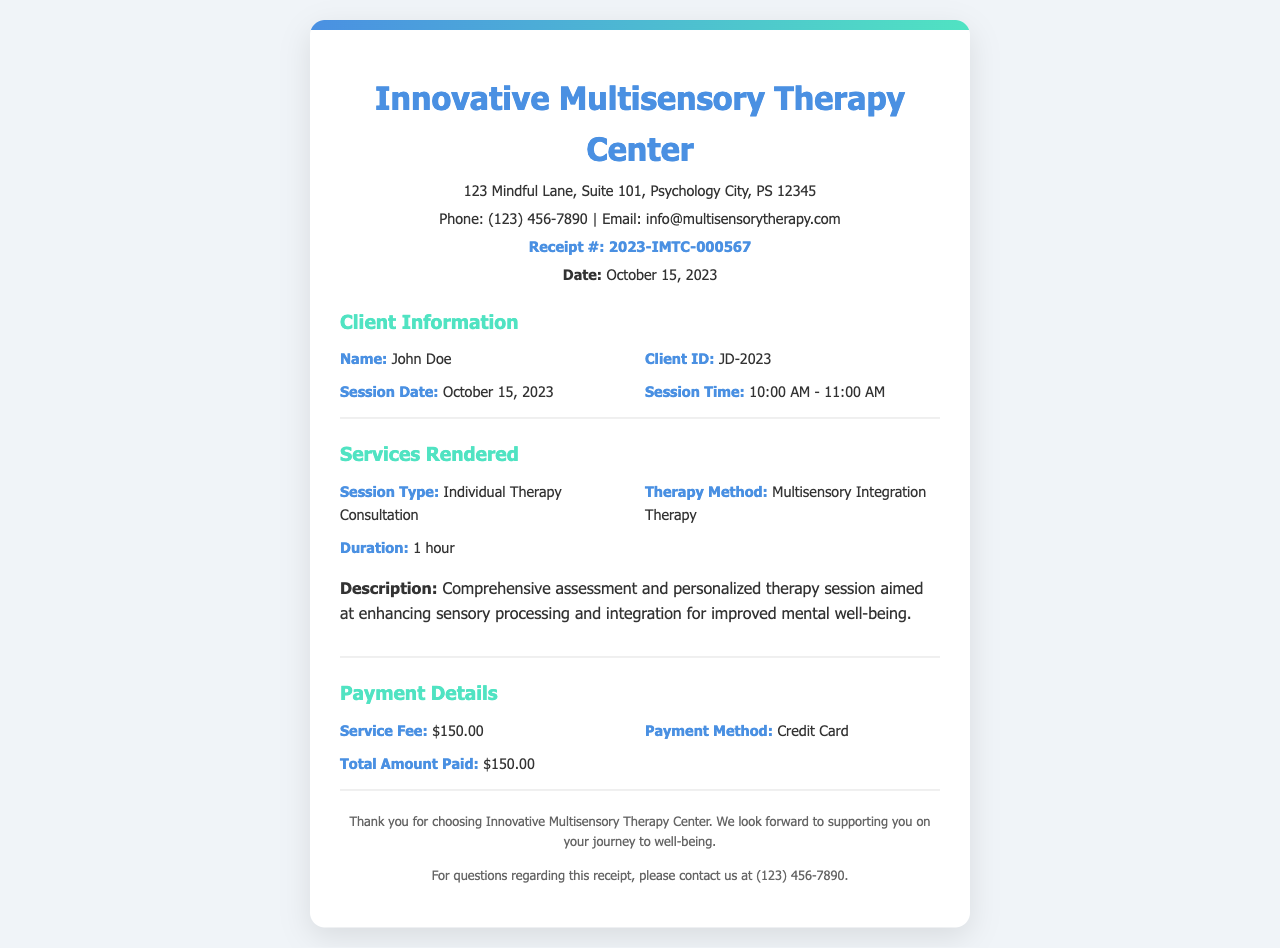What is the client's name? The client's name is explicitly stated in the document under "Client Information."
Answer: John Doe What is the session type? The session type is specified in the "Services Rendered" section of the document.
Answer: Individual Therapy Consultation What is the session duration? The duration of the session is provided alongside the service details in the document.
Answer: 1 hour What was the total amount paid? The total amount paid is clearly stated in the "Payment Details" section of the receipt.
Answer: $150.00 What method of payment was used? The payment method is specified under "Payment Details" within the document.
Answer: Credit Card On what date was the therapy session conducted? The therapy session date is mentioned under "Client Information" in the document.
Answer: October 15, 2023 What therapy method was employed during the session? The therapy method is outlined in the "Services Rendered" section of the receipt.
Answer: Multisensory Integration Therapy What is the receipt number? The receipt number is provided prominently at the top of the document.
Answer: 2023-IMTC-000567 What is the address of the therapy center? The address is given in the header section of the receipt.
Answer: 123 Mindful Lane, Suite 101, Psychology City, PS 12345 